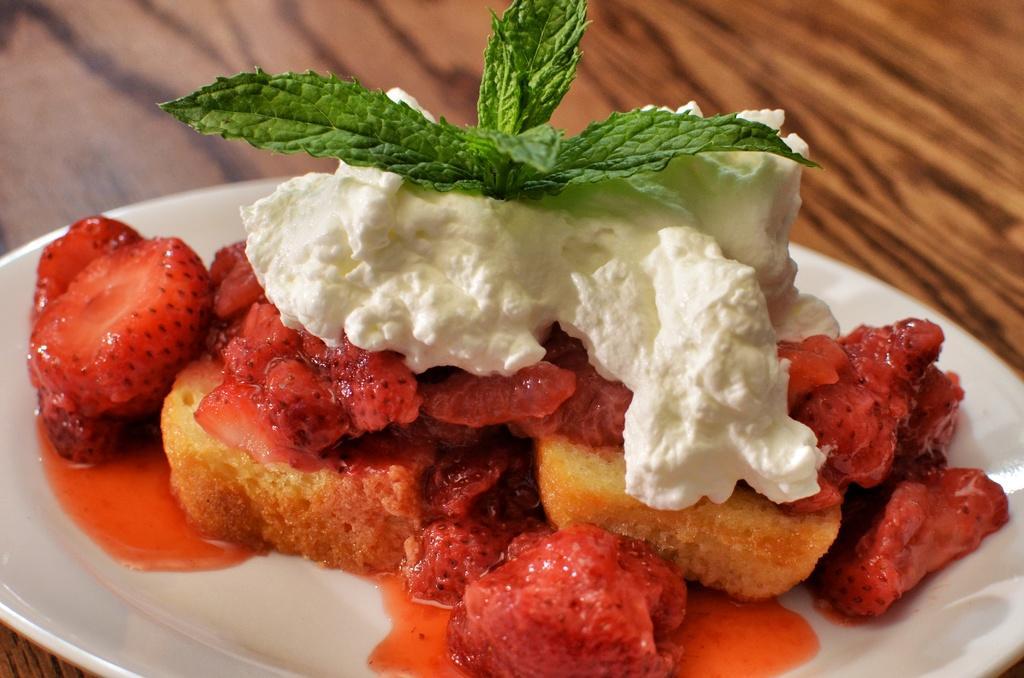Can you describe this image briefly? In the image there is a plate with strawberries,bread,ice cream and mint leaves on it on a wooden table. 